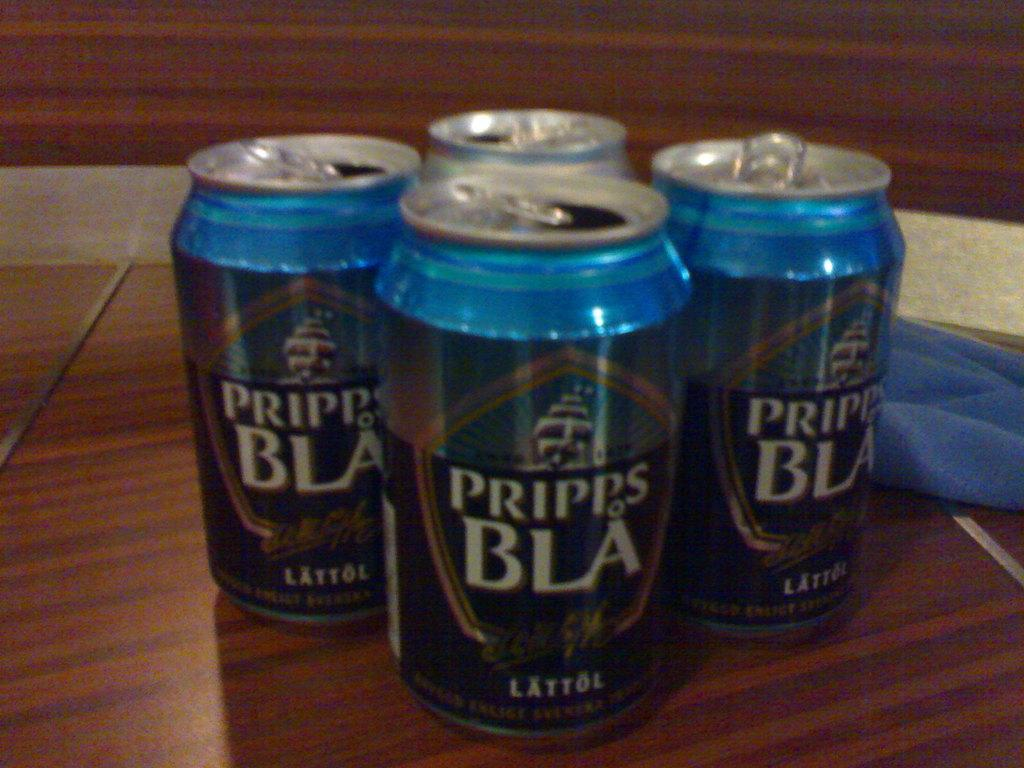Provide a one-sentence caption for the provided image. Four cans of Pripps BLA are open on a wooden tabletop. 